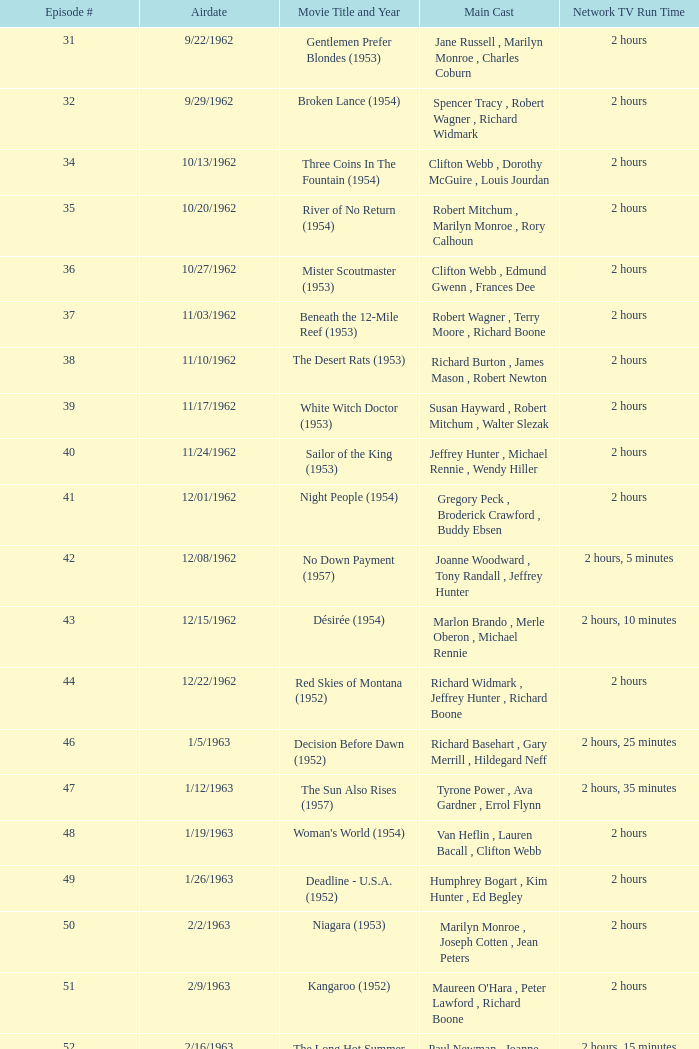Which film featured dana wynter, mel ferrer, and theodore bikel as its stars? Fraulein (1958). 